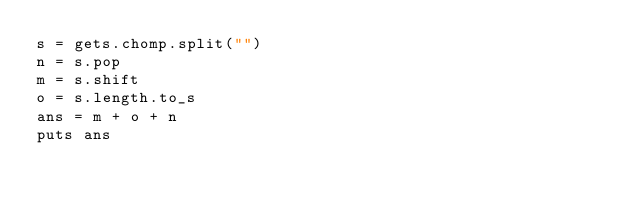<code> <loc_0><loc_0><loc_500><loc_500><_Ruby_>s = gets.chomp.split("")
n = s.pop
m = s.shift
o = s.length.to_s
ans = m + o + n
puts ans
</code> 